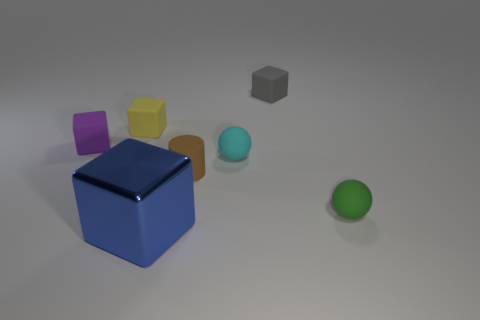Does the purple matte block have the same size as the matte ball behind the rubber cylinder?
Your response must be concise. Yes. There is a object that is in front of the brown object and behind the blue thing; what shape is it?
Ensure brevity in your answer.  Sphere. The brown thing that is made of the same material as the small yellow block is what size?
Give a very brief answer. Small. There is a tiny matte sphere to the left of the small green sphere; what number of tiny cubes are behind it?
Offer a terse response. 3. Is the block in front of the small purple thing made of the same material as the gray thing?
Make the answer very short. No. Are there any other things that have the same material as the tiny cylinder?
Ensure brevity in your answer.  Yes. There is a matte ball that is to the left of the small matte sphere that is in front of the tiny brown object; how big is it?
Give a very brief answer. Small. What is the size of the matte cube that is right of the ball on the left side of the small cube on the right side of the blue shiny block?
Ensure brevity in your answer.  Small. Is the shape of the big blue thing that is on the left side of the tiny brown rubber cylinder the same as the small object that is on the left side of the yellow thing?
Make the answer very short. Yes. What number of other objects are the same color as the large shiny block?
Your response must be concise. 0. 